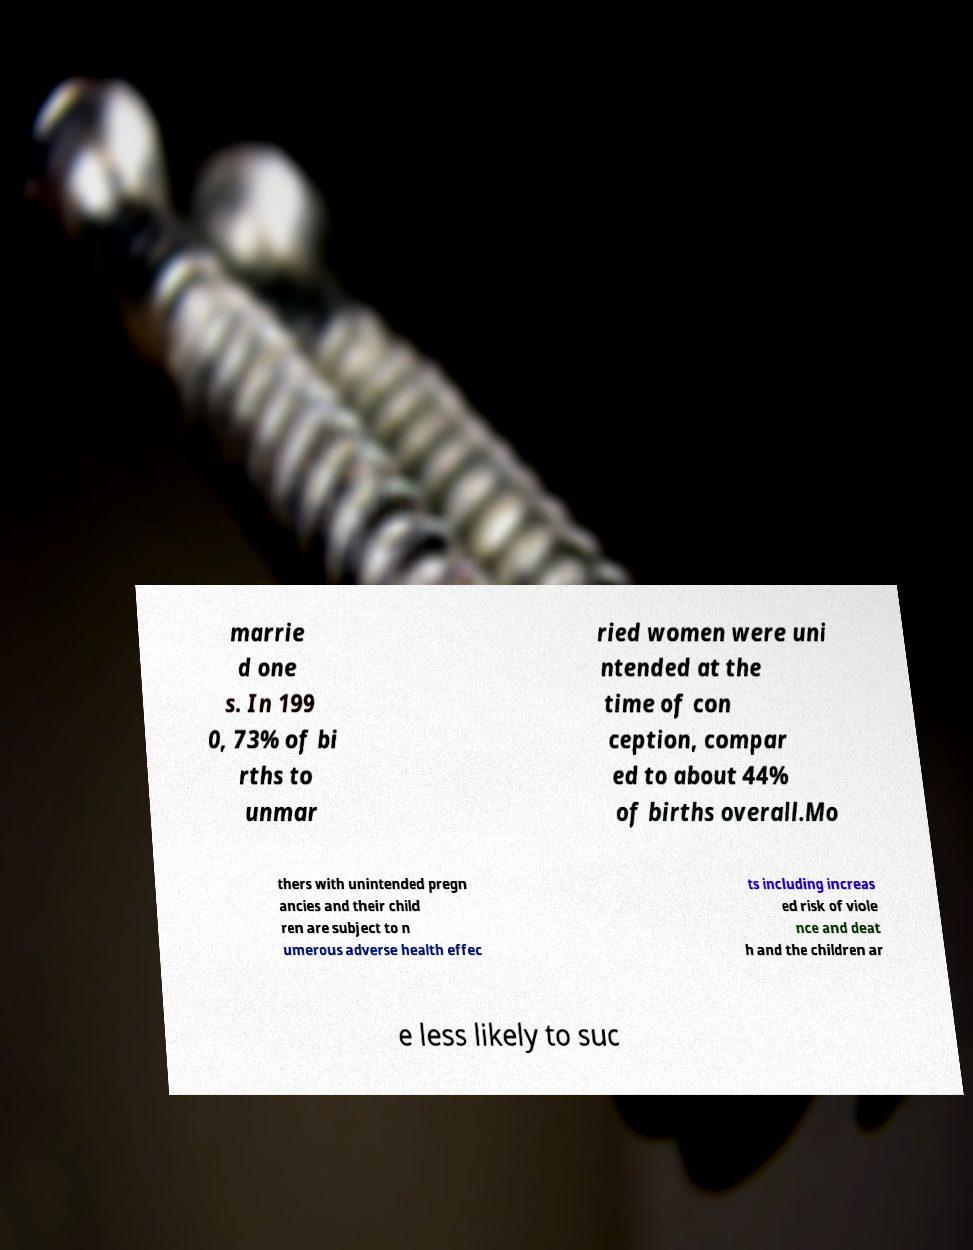Could you extract and type out the text from this image? marrie d one s. In 199 0, 73% of bi rths to unmar ried women were uni ntended at the time of con ception, compar ed to about 44% of births overall.Mo thers with unintended pregn ancies and their child ren are subject to n umerous adverse health effec ts including increas ed risk of viole nce and deat h and the children ar e less likely to suc 